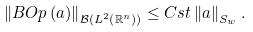<formula> <loc_0><loc_0><loc_500><loc_500>\left \| B O p \left ( a \right ) \right \| _ { \mathcal { B } \left ( L ^ { 2 } \left ( \mathbb { R } ^ { n } \right ) \right ) } \leq C s t \left \| a \right \| _ { S _ { w } } .</formula> 